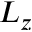Convert formula to latex. <formula><loc_0><loc_0><loc_500><loc_500>L _ { z }</formula> 